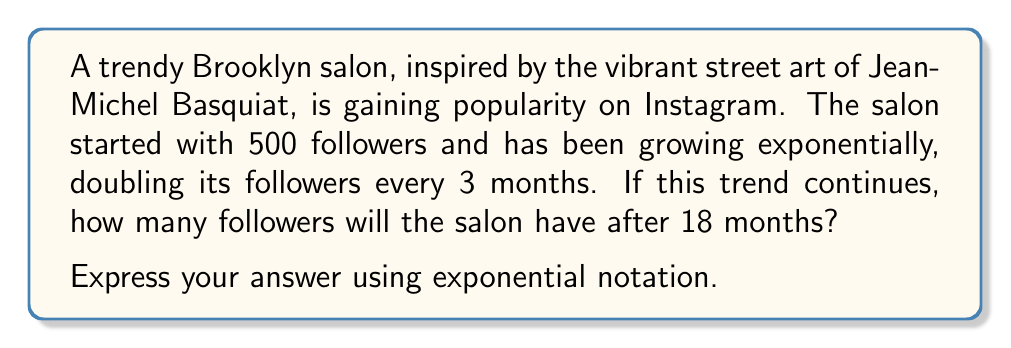Teach me how to tackle this problem. Let's approach this step-by-step:

1) We can model this situation using an exponential function in the form:
   $$ f(t) = a \cdot b^t $$
   where $a$ is the initial number of followers, $b$ is the growth factor, and $t$ is the time in units of 3 months.

2) We know:
   - Initial followers, $a = 500$
   - The number of followers doubles every 3 months, so $b = 2$
   - We want to know the number of followers after 18 months, which is 6 units of 3 months, so $t = 6$

3) Substituting these values into our function:
   $$ f(6) = 500 \cdot 2^6 $$

4) Now, let's calculate $2^6$:
   $$ 2^6 = 2 \cdot 2 \cdot 2 \cdot 2 \cdot 2 \cdot 2 = 64 $$

5) Therefore:
   $$ f(6) = 500 \cdot 64 = 32,000 $$

Thus, after 18 months, the salon will have 32,000 followers.
Answer: $500 \cdot 2^6$ or $32,000$ 